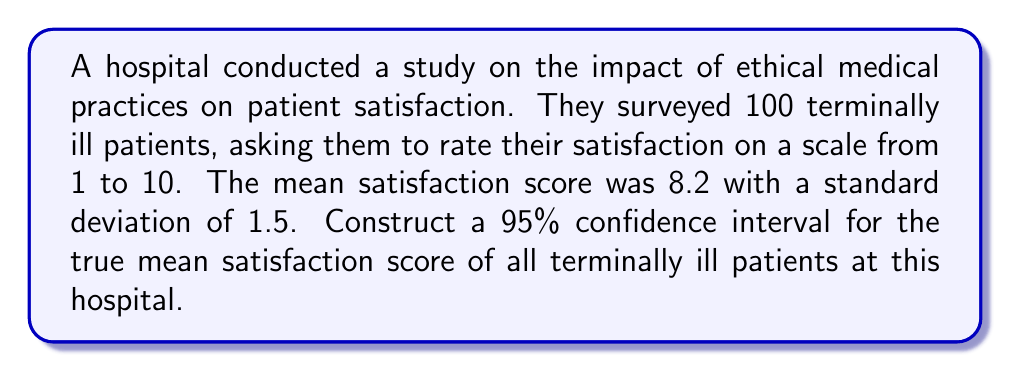Give your solution to this math problem. To construct a 95% confidence interval for the true mean satisfaction score, we'll follow these steps:

1. Identify the known values:
   - Sample size: $n = 100$
   - Sample mean: $\bar{x} = 8.2$
   - Sample standard deviation: $s = 1.5$
   - Confidence level: 95% (α = 0.05)

2. Determine the critical value:
   For a 95% confidence interval with large sample size (n > 30), we use the z-score: $z_{α/2} = 1.96$

3. Calculate the standard error of the mean:
   $SE = \frac{s}{\sqrt{n}} = \frac{1.5}{\sqrt{100}} = \frac{1.5}{10} = 0.15$

4. Compute the margin of error:
   $ME = z_{α/2} \cdot SE = 1.96 \cdot 0.15 = 0.294$

5. Construct the confidence interval:
   $CI = \bar{x} \pm ME$
   $CI = 8.2 \pm 0.294$
   $CI = (8.2 - 0.294, 8.2 + 0.294)$
   $CI = (7.906, 8.494)$

Therefore, we can be 95% confident that the true mean satisfaction score for all terminally ill patients at this hospital falls between 7.906 and 8.494.
Answer: (7.906, 8.494) 